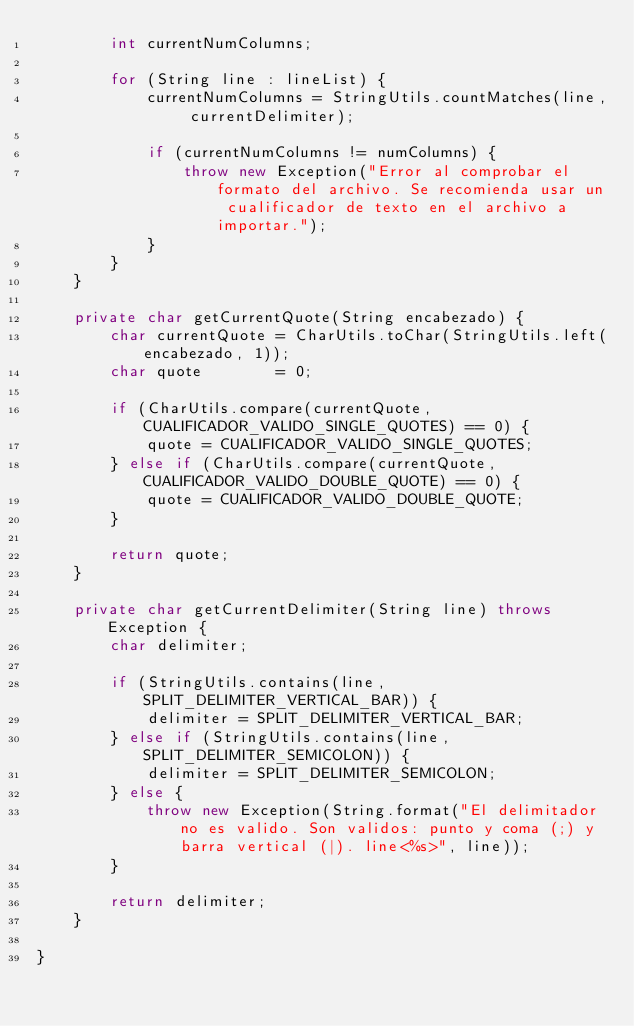Convert code to text. <code><loc_0><loc_0><loc_500><loc_500><_Java_>        int currentNumColumns;
        
        for (String line : lineList) {
            currentNumColumns = StringUtils.countMatches(line, currentDelimiter);
            
            if (currentNumColumns != numColumns) {
                throw new Exception("Error al comprobar el formato del archivo. Se recomienda usar un cualificador de texto en el archivo a importar.");
            }
        }
    }
    
    private char getCurrentQuote(String encabezado) {
        char currentQuote = CharUtils.toChar(StringUtils.left(encabezado, 1));
        char quote        = 0;
        
        if (CharUtils.compare(currentQuote, CUALIFICADOR_VALIDO_SINGLE_QUOTES) == 0) {
            quote = CUALIFICADOR_VALIDO_SINGLE_QUOTES;
        } else if (CharUtils.compare(currentQuote, CUALIFICADOR_VALIDO_DOUBLE_QUOTE) == 0) {
            quote = CUALIFICADOR_VALIDO_DOUBLE_QUOTE;
        }
        
        return quote;
    }
    
    private char getCurrentDelimiter(String line) throws Exception {
        char delimiter;
        
        if (StringUtils.contains(line, SPLIT_DELIMITER_VERTICAL_BAR)) {
            delimiter = SPLIT_DELIMITER_VERTICAL_BAR;
        } else if (StringUtils.contains(line, SPLIT_DELIMITER_SEMICOLON)) {
            delimiter = SPLIT_DELIMITER_SEMICOLON;
        } else {
            throw new Exception(String.format("El delimitador no es valido. Son validos: punto y coma (;) y barra vertical (|). line<%s>", line));
        }
        
        return delimiter;
    }
    
}
</code> 